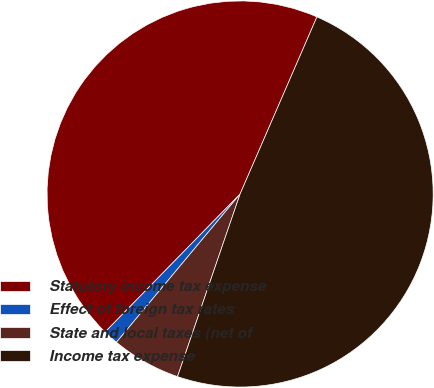Convert chart. <chart><loc_0><loc_0><loc_500><loc_500><pie_chart><fcel>Statutory income tax expense<fcel>Effect of foreign tax rates<fcel>State and local taxes (net of<fcel>Income tax expense<nl><fcel>44.19%<fcel>1.26%<fcel>5.81%<fcel>48.74%<nl></chart> 